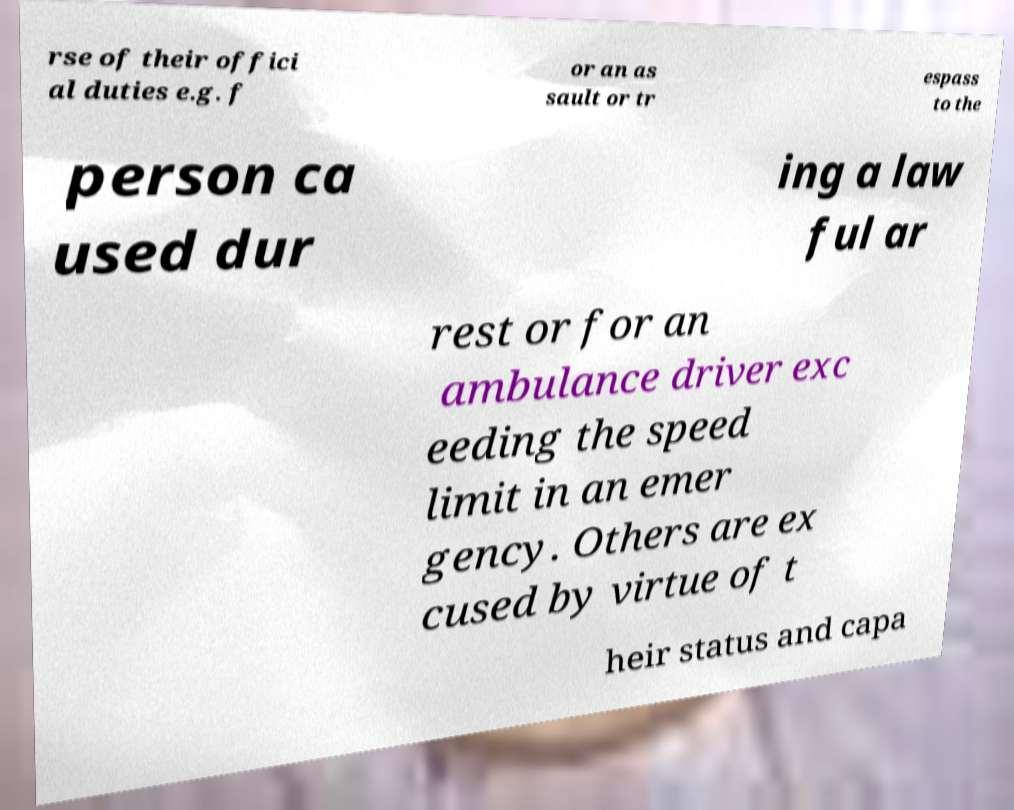Please read and relay the text visible in this image. What does it say? rse of their offici al duties e.g. f or an as sault or tr espass to the person ca used dur ing a law ful ar rest or for an ambulance driver exc eeding the speed limit in an emer gency. Others are ex cused by virtue of t heir status and capa 